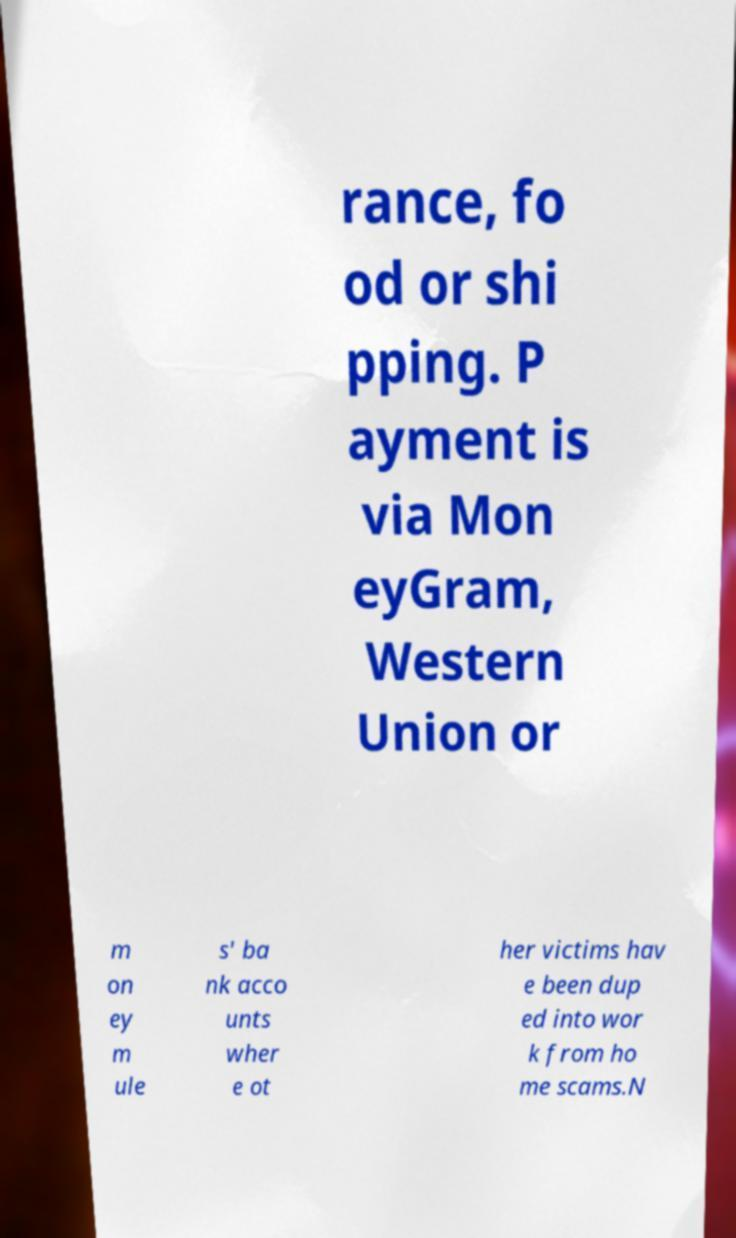Please identify and transcribe the text found in this image. rance, fo od or shi pping. P ayment is via Mon eyGram, Western Union or m on ey m ule s' ba nk acco unts wher e ot her victims hav e been dup ed into wor k from ho me scams.N 